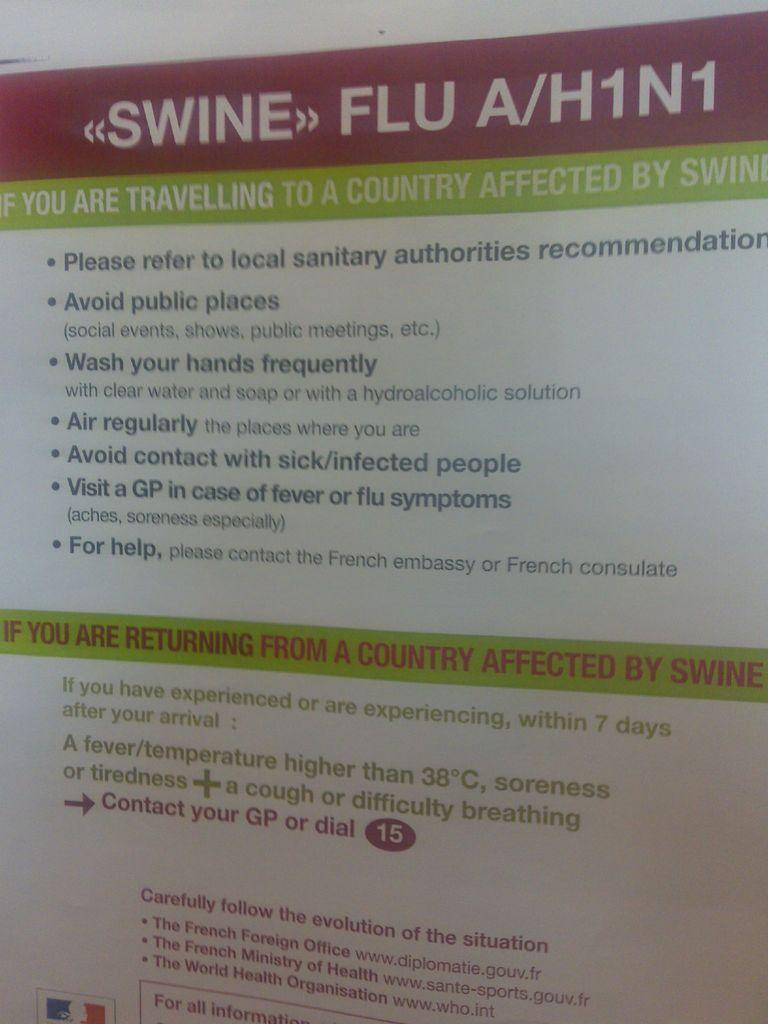<image>
Share a concise interpretation of the image provided. A poster for Swine Flu hangs from a wall with information about traveling to affected countries 